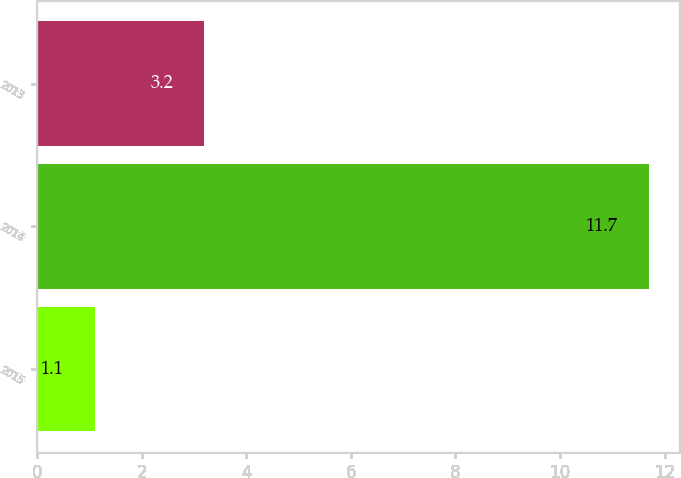Convert chart to OTSL. <chart><loc_0><loc_0><loc_500><loc_500><bar_chart><fcel>2015<fcel>2014<fcel>2013<nl><fcel>1.1<fcel>11.7<fcel>3.2<nl></chart> 